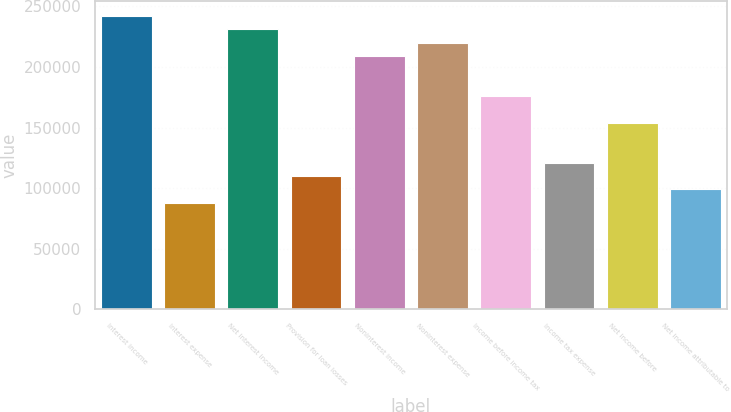Convert chart to OTSL. <chart><loc_0><loc_0><loc_500><loc_500><bar_chart><fcel>Interest income<fcel>Interest expense<fcel>Net interest income<fcel>Provision for loan losses<fcel>Noninterest income<fcel>Noninterest expense<fcel>Income before income tax<fcel>Income tax expense<fcel>Net income before<fcel>Net income attributable to<nl><fcel>242041<fcel>88015.2<fcel>231039<fcel>110019<fcel>209036<fcel>220038<fcel>176030<fcel>121021<fcel>154026<fcel>99017.1<nl></chart> 